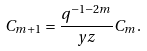Convert formula to latex. <formula><loc_0><loc_0><loc_500><loc_500>C _ { m + 1 } = \frac { q ^ { - 1 - 2 m } } { y z } C _ { m } .</formula> 